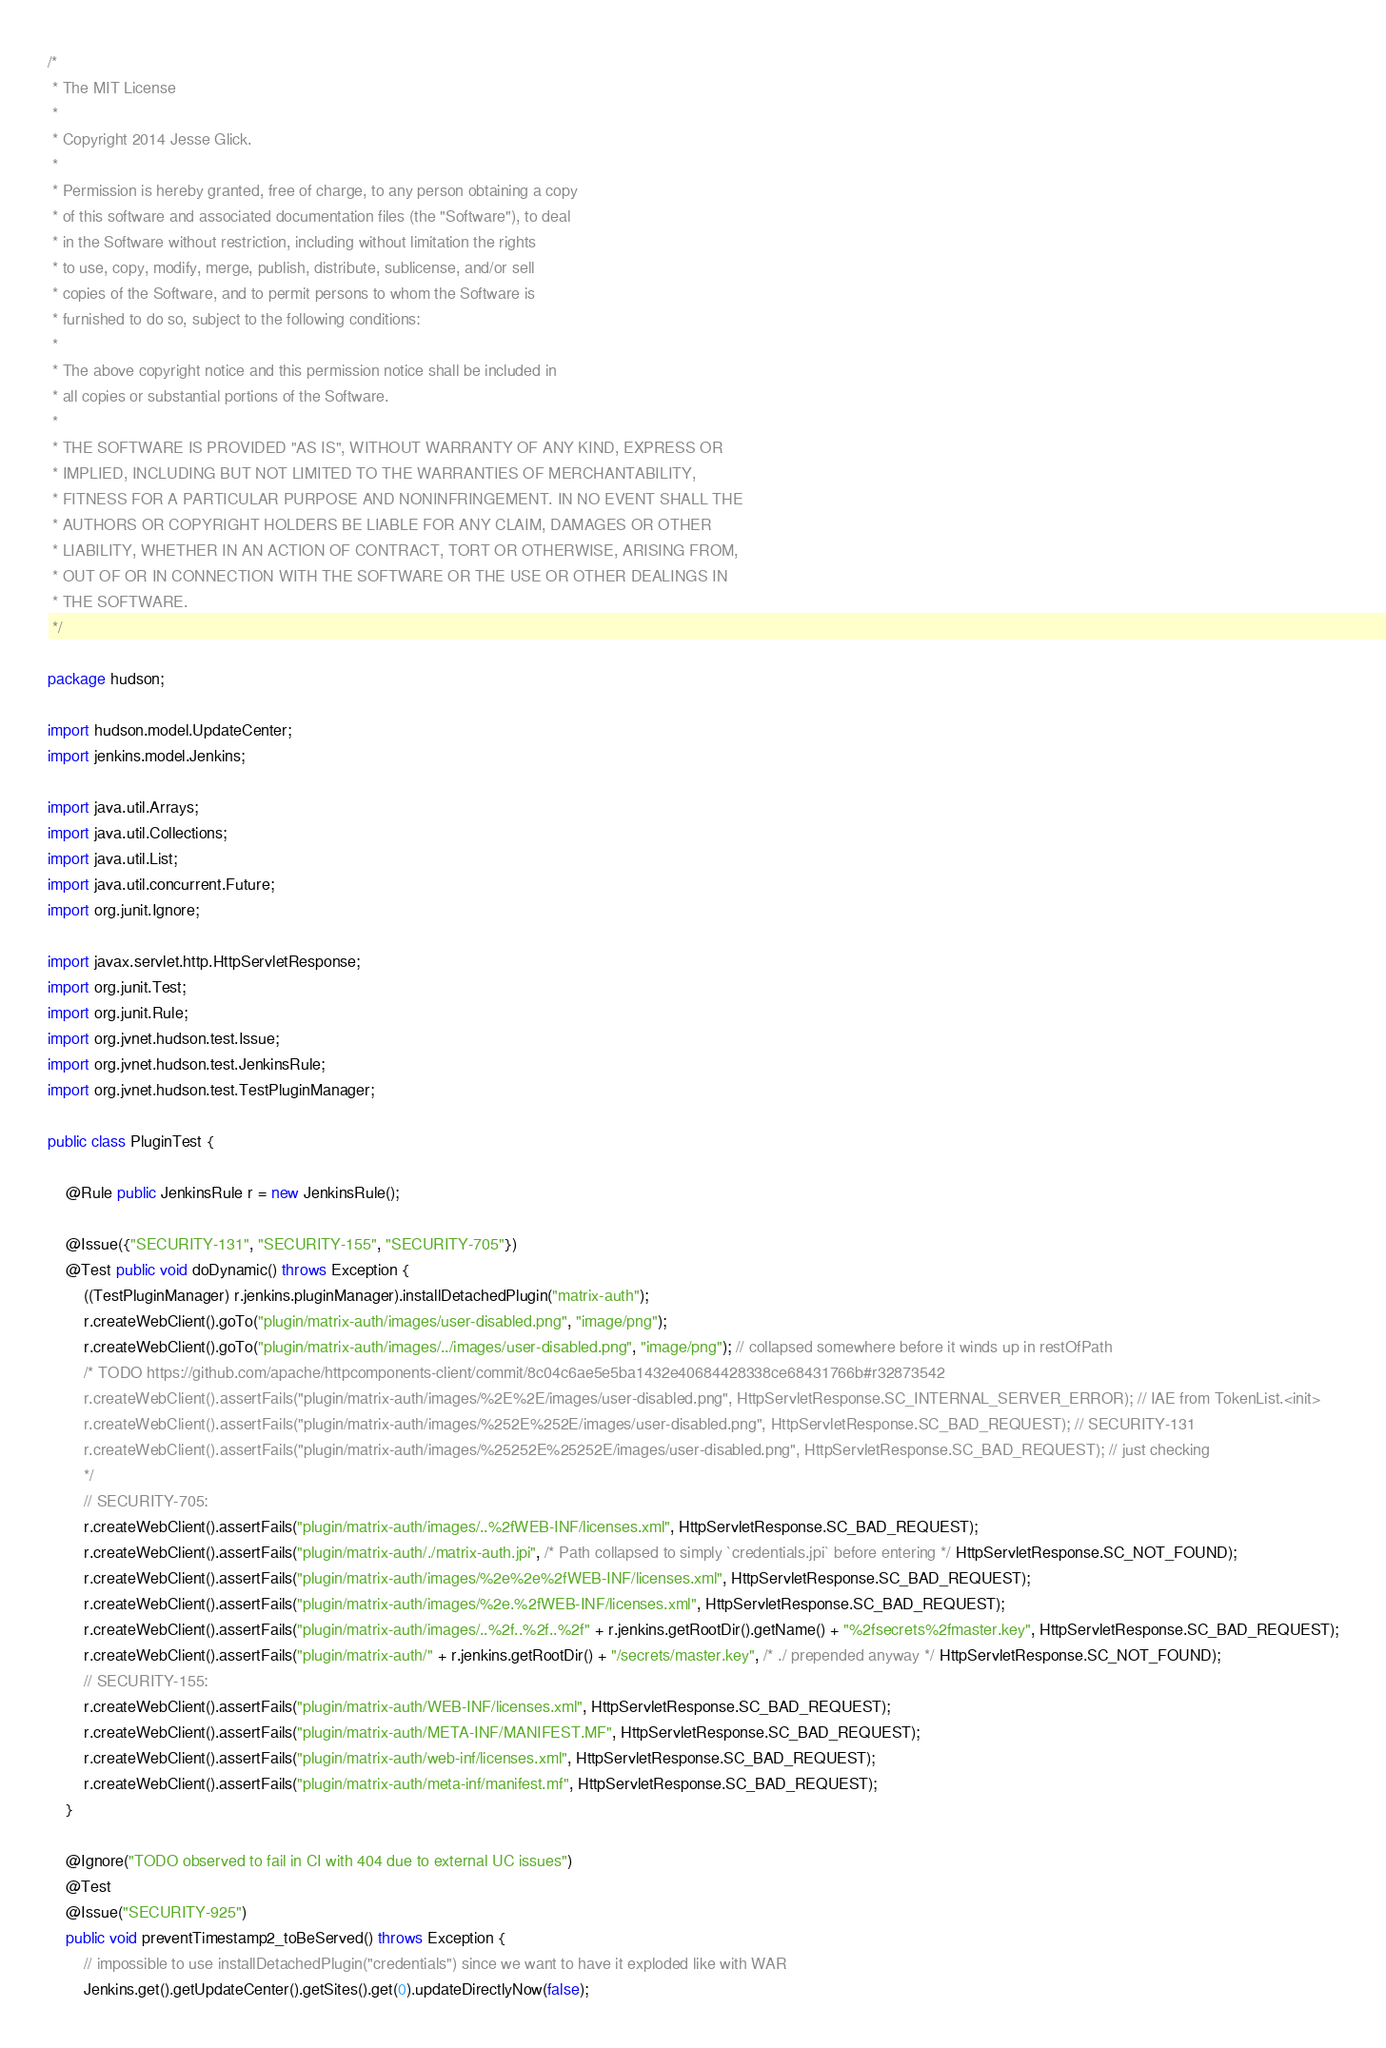<code> <loc_0><loc_0><loc_500><loc_500><_Java_>/*
 * The MIT License
 *
 * Copyright 2014 Jesse Glick.
 *
 * Permission is hereby granted, free of charge, to any person obtaining a copy
 * of this software and associated documentation files (the "Software"), to deal
 * in the Software without restriction, including without limitation the rights
 * to use, copy, modify, merge, publish, distribute, sublicense, and/or sell
 * copies of the Software, and to permit persons to whom the Software is
 * furnished to do so, subject to the following conditions:
 *
 * The above copyright notice and this permission notice shall be included in
 * all copies or substantial portions of the Software.
 *
 * THE SOFTWARE IS PROVIDED "AS IS", WITHOUT WARRANTY OF ANY KIND, EXPRESS OR
 * IMPLIED, INCLUDING BUT NOT LIMITED TO THE WARRANTIES OF MERCHANTABILITY,
 * FITNESS FOR A PARTICULAR PURPOSE AND NONINFRINGEMENT. IN NO EVENT SHALL THE
 * AUTHORS OR COPYRIGHT HOLDERS BE LIABLE FOR ANY CLAIM, DAMAGES OR OTHER
 * LIABILITY, WHETHER IN AN ACTION OF CONTRACT, TORT OR OTHERWISE, ARISING FROM,
 * OUT OF OR IN CONNECTION WITH THE SOFTWARE OR THE USE OR OTHER DEALINGS IN
 * THE SOFTWARE.
 */

package hudson;

import hudson.model.UpdateCenter;
import jenkins.model.Jenkins;

import java.util.Arrays;
import java.util.Collections;
import java.util.List;
import java.util.concurrent.Future;
import org.junit.Ignore;

import javax.servlet.http.HttpServletResponse;
import org.junit.Test;
import org.junit.Rule;
import org.jvnet.hudson.test.Issue;
import org.jvnet.hudson.test.JenkinsRule;
import org.jvnet.hudson.test.TestPluginManager;

public class PluginTest {

    @Rule public JenkinsRule r = new JenkinsRule();

    @Issue({"SECURITY-131", "SECURITY-155", "SECURITY-705"})
    @Test public void doDynamic() throws Exception {
        ((TestPluginManager) r.jenkins.pluginManager).installDetachedPlugin("matrix-auth");
        r.createWebClient().goTo("plugin/matrix-auth/images/user-disabled.png", "image/png");
        r.createWebClient().goTo("plugin/matrix-auth/images/../images/user-disabled.png", "image/png"); // collapsed somewhere before it winds up in restOfPath
        /* TODO https://github.com/apache/httpcomponents-client/commit/8c04c6ae5e5ba1432e40684428338ce68431766b#r32873542
        r.createWebClient().assertFails("plugin/matrix-auth/images/%2E%2E/images/user-disabled.png", HttpServletResponse.SC_INTERNAL_SERVER_ERROR); // IAE from TokenList.<init>
        r.createWebClient().assertFails("plugin/matrix-auth/images/%252E%252E/images/user-disabled.png", HttpServletResponse.SC_BAD_REQUEST); // SECURITY-131
        r.createWebClient().assertFails("plugin/matrix-auth/images/%25252E%25252E/images/user-disabled.png", HttpServletResponse.SC_BAD_REQUEST); // just checking
        */
        // SECURITY-705:
        r.createWebClient().assertFails("plugin/matrix-auth/images/..%2fWEB-INF/licenses.xml", HttpServletResponse.SC_BAD_REQUEST);
        r.createWebClient().assertFails("plugin/matrix-auth/./matrix-auth.jpi", /* Path collapsed to simply `credentials.jpi` before entering */ HttpServletResponse.SC_NOT_FOUND);
        r.createWebClient().assertFails("plugin/matrix-auth/images/%2e%2e%2fWEB-INF/licenses.xml", HttpServletResponse.SC_BAD_REQUEST);
        r.createWebClient().assertFails("plugin/matrix-auth/images/%2e.%2fWEB-INF/licenses.xml", HttpServletResponse.SC_BAD_REQUEST);
        r.createWebClient().assertFails("plugin/matrix-auth/images/..%2f..%2f..%2f" + r.jenkins.getRootDir().getName() + "%2fsecrets%2fmaster.key", HttpServletResponse.SC_BAD_REQUEST);
        r.createWebClient().assertFails("plugin/matrix-auth/" + r.jenkins.getRootDir() + "/secrets/master.key", /* ./ prepended anyway */ HttpServletResponse.SC_NOT_FOUND);
        // SECURITY-155:
        r.createWebClient().assertFails("plugin/matrix-auth/WEB-INF/licenses.xml", HttpServletResponse.SC_BAD_REQUEST);
        r.createWebClient().assertFails("plugin/matrix-auth/META-INF/MANIFEST.MF", HttpServletResponse.SC_BAD_REQUEST);
        r.createWebClient().assertFails("plugin/matrix-auth/web-inf/licenses.xml", HttpServletResponse.SC_BAD_REQUEST);
        r.createWebClient().assertFails("plugin/matrix-auth/meta-inf/manifest.mf", HttpServletResponse.SC_BAD_REQUEST);
    }

    @Ignore("TODO observed to fail in CI with 404 due to external UC issues")
    @Test
    @Issue("SECURITY-925")
    public void preventTimestamp2_toBeServed() throws Exception {
        // impossible to use installDetachedPlugin("credentials") since we want to have it exploded like with WAR
        Jenkins.get().getUpdateCenter().getSites().get(0).updateDirectlyNow(false);</code> 